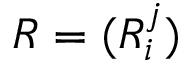Convert formula to latex. <formula><loc_0><loc_0><loc_500><loc_500>R = ( R _ { i } ^ { j } )</formula> 